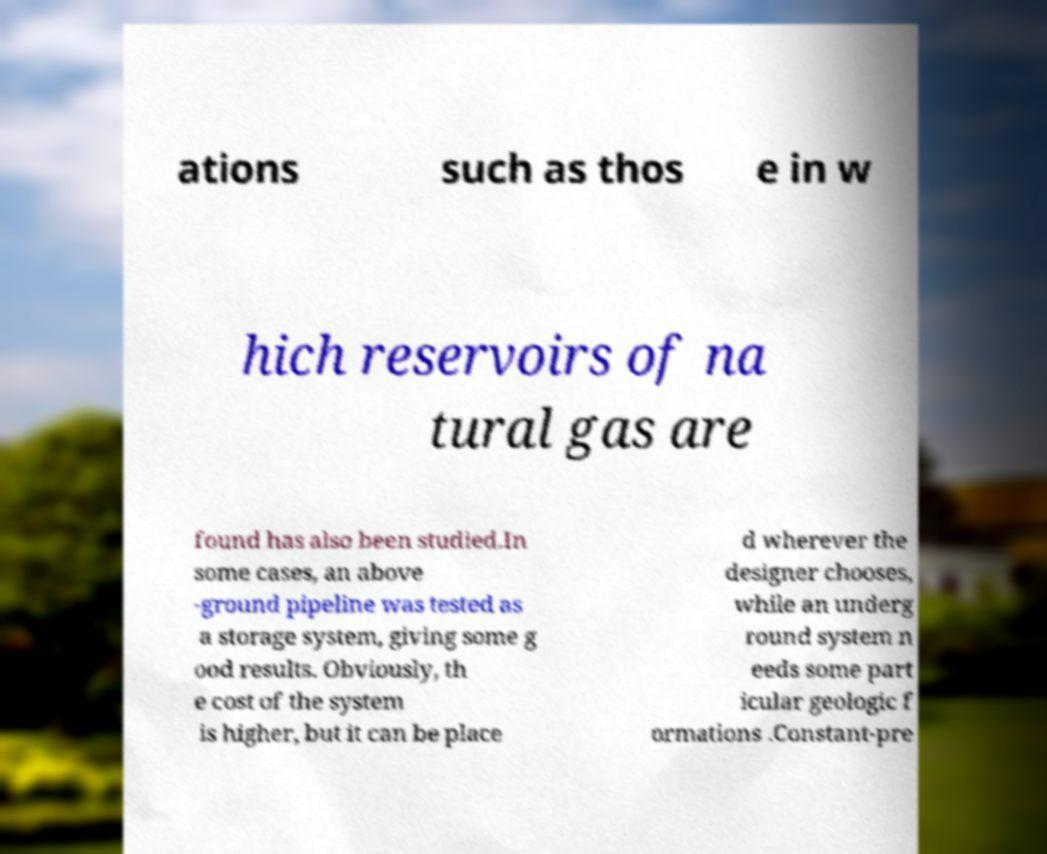Could you assist in decoding the text presented in this image and type it out clearly? ations such as thos e in w hich reservoirs of na tural gas are found has also been studied.In some cases, an above -ground pipeline was tested as a storage system, giving some g ood results. Obviously, th e cost of the system is higher, but it can be place d wherever the designer chooses, while an underg round system n eeds some part icular geologic f ormations .Constant-pre 